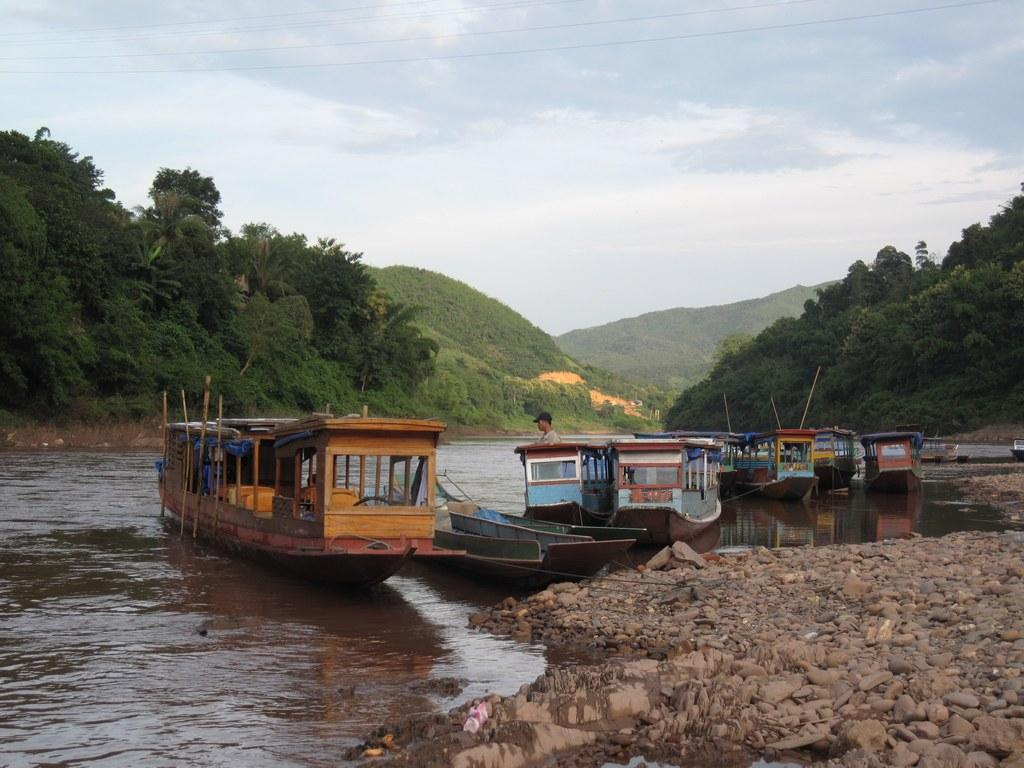What is happening in the water in the image? There are boats sailing on the water in the image. What can be seen in the distance behind the water? There are mountains in the backdrop of the image. How would you describe the sky in the image? The sky is clear in the image. How many chairs are placed on the boats in the image? There are no chairs visible on the boats in the image. What type of balls are being used for the game in the image? There is no game or balls present in the image; it features boats sailing on the water with mountains in the backdrop and a clear sky. 